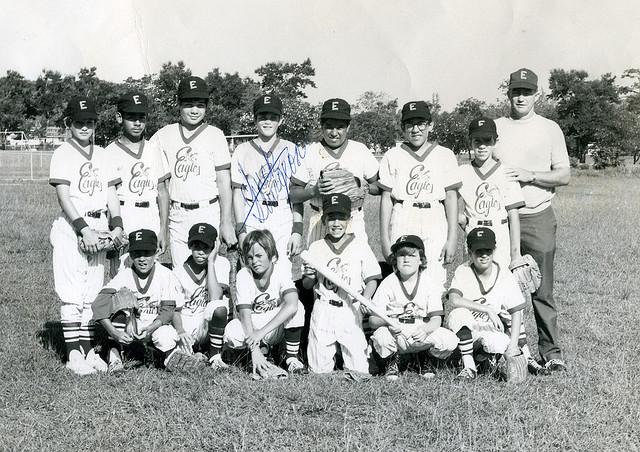Is this a family picture?
Keep it brief. No. Is this a professional team?
Be succinct. No. Are they wearing lab coats?
Write a very short answer. No. What Academy is the team from?
Keep it brief. Eagles. How many people are in the pic?
Short answer required. 14. Is this picture signed?
Answer briefly. Yes. How many men are not wearing the team uniform?
Short answer required. 1. Are the people competing?
Write a very short answer. No. 